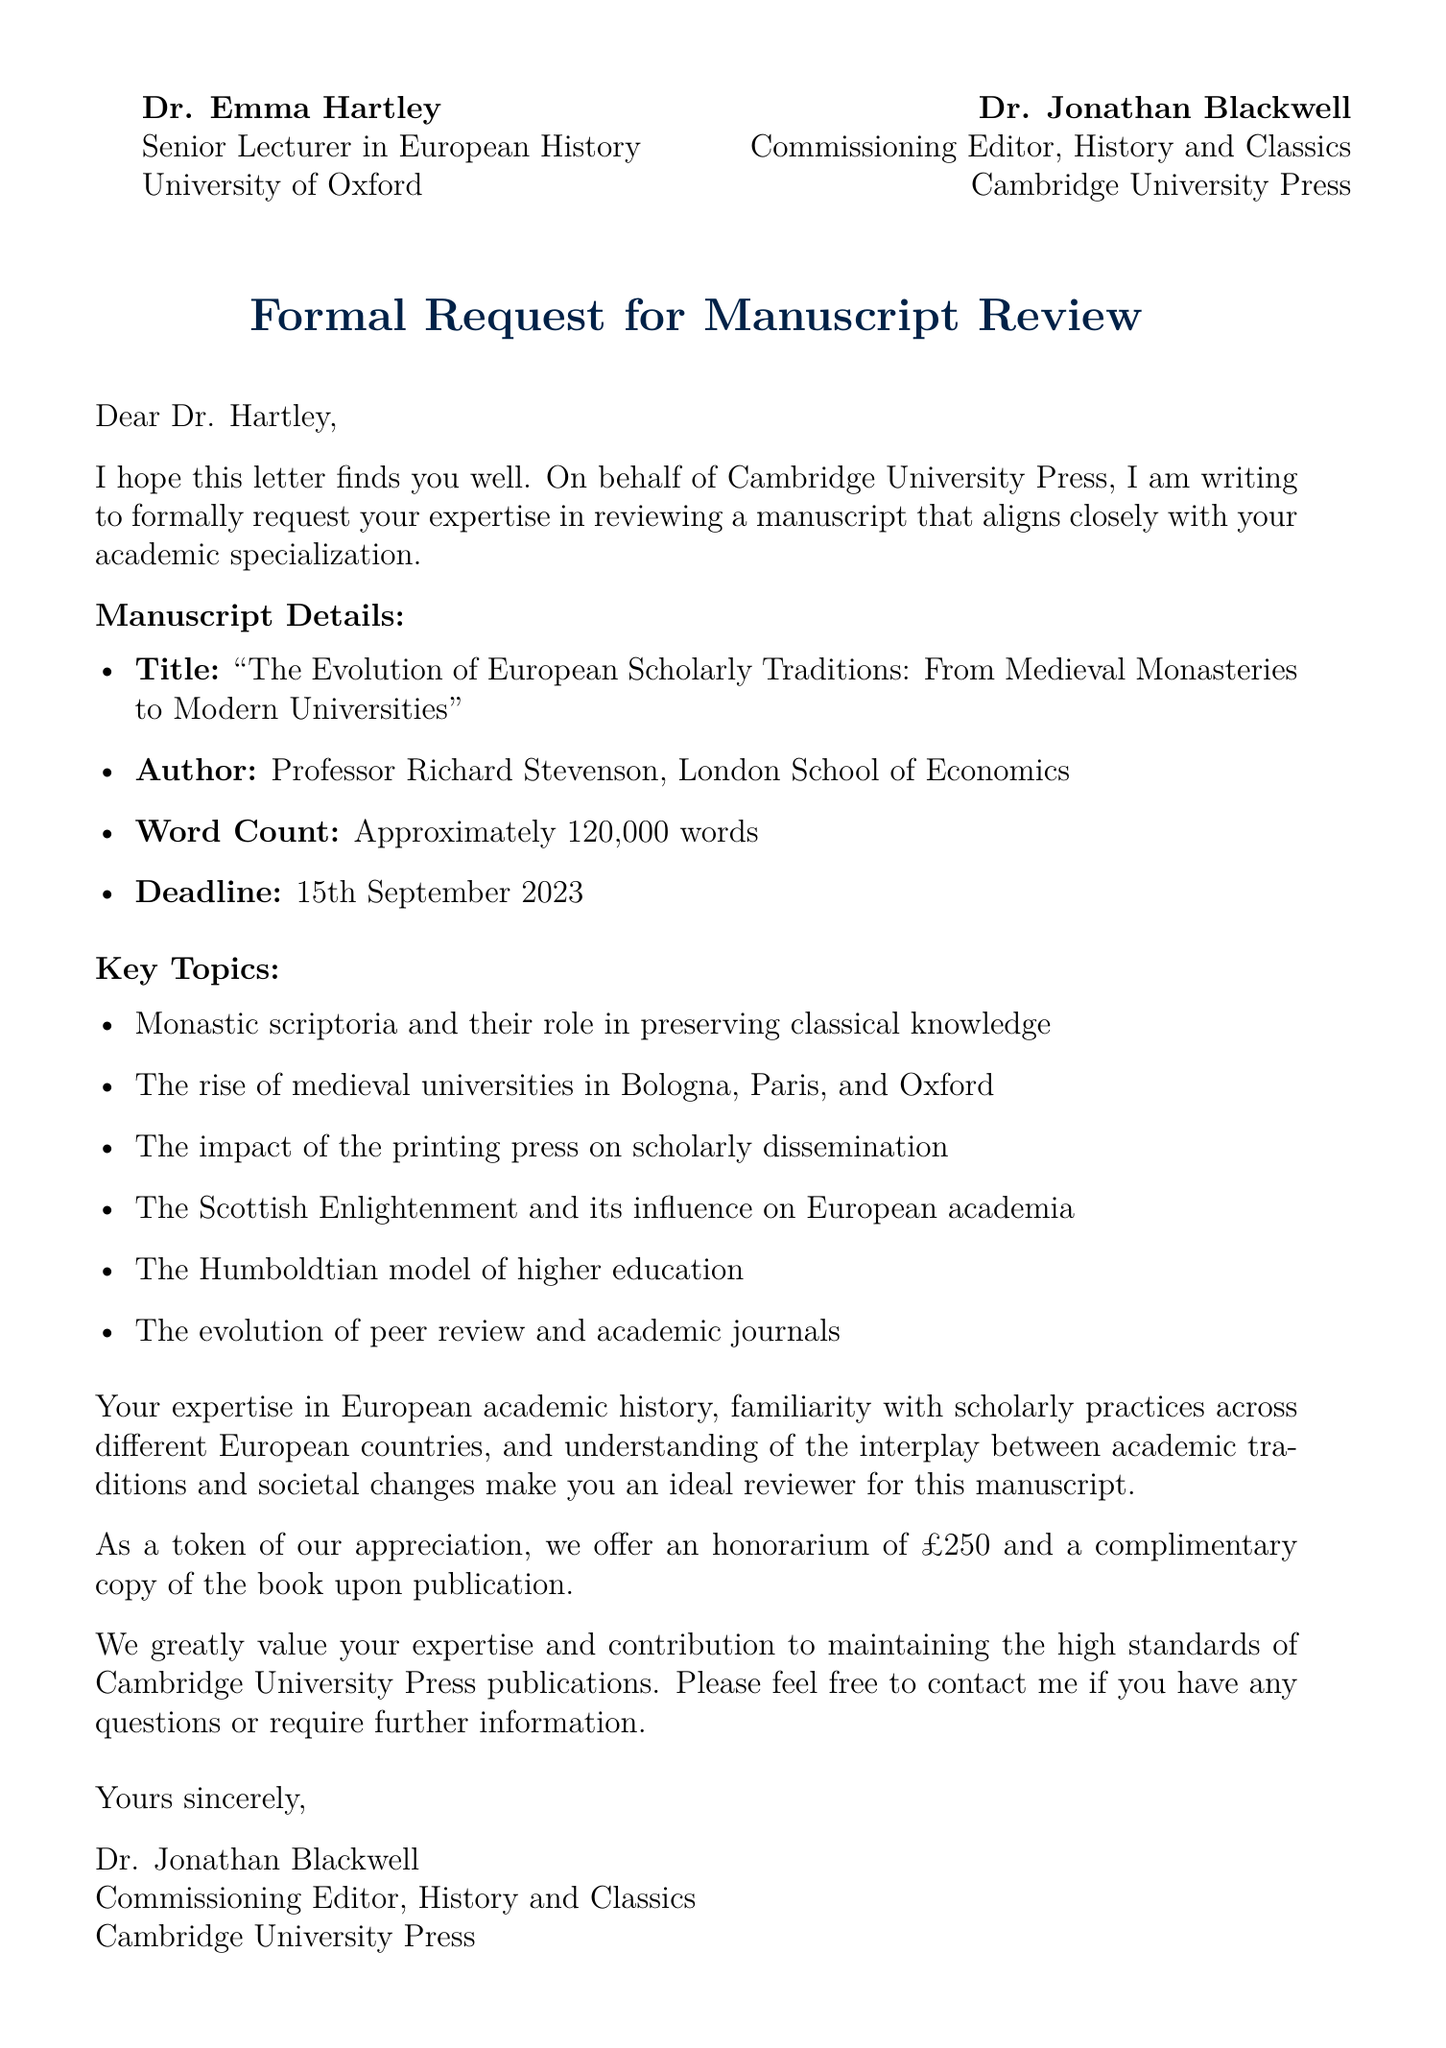What is the title of the manuscript? The title is explicitly stated in the document and is the focus of the review request.
Answer: The Evolution of European Scholarly Traditions: From Medieval Monasteries to Modern Universities Who is the author of the manuscript? The author's name is mentioned in the manuscript details section of the document.
Answer: Professor Richard Stevenson What is the word count of the manuscript? The document provides a specific word count for the manuscript, relevant for assessing the review process.
Answer: Approximately 120,000 words What is the deadline for the manuscript review? The deadline is clearly indicated in the document as a specific date.
Answer: 15th September 2023 What is the honorarium offered for the review? The document mentions a specific monetary amount as compensation for the review service.
Answer: £250 Which university is Dr. Hartley affiliated with? Dr. Hartley's institutional affiliation is listed in the opening of the letter.
Answer: University of Oxford What role does Dr. Jonathan Blackwell hold at Cambridge University Press? The document specifies Dr. Blackwell's title and department, which identifies his position.
Answer: Commissioning Editor What topic is not mentioned among the key topics of the manuscript? An understanding of the key topics allows for reasoning about what is included or excluded.
Answer: Not applicable (as reasoning question - requires identifying non-mentioned topics) Why is Dr. Hartley considered an ideal reviewer? The document lists specific qualifications and expertise that justify this designation.
Answer: Extensive knowledge of European academic history, familiarity with the development of scholarly practices across different European countries, understanding of the interplay between academic traditions and societal changes 